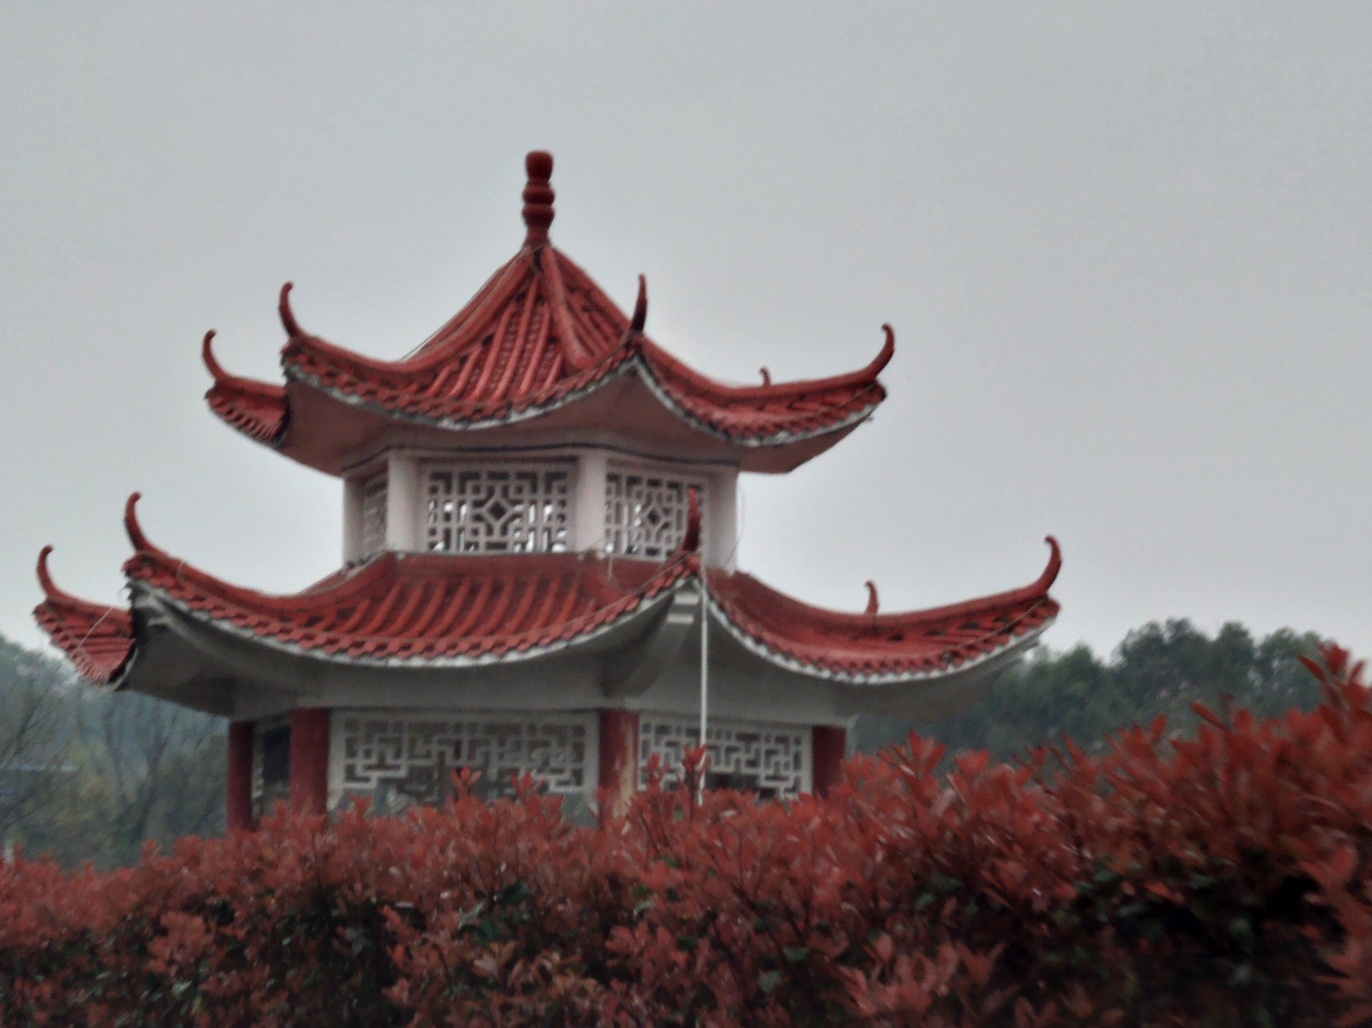What is the composition of this image?
A. Strongly tilted
B. Slightly tilted
C. Completely horizontal
Answer with the option's letter from the given choices directly.
 B. 